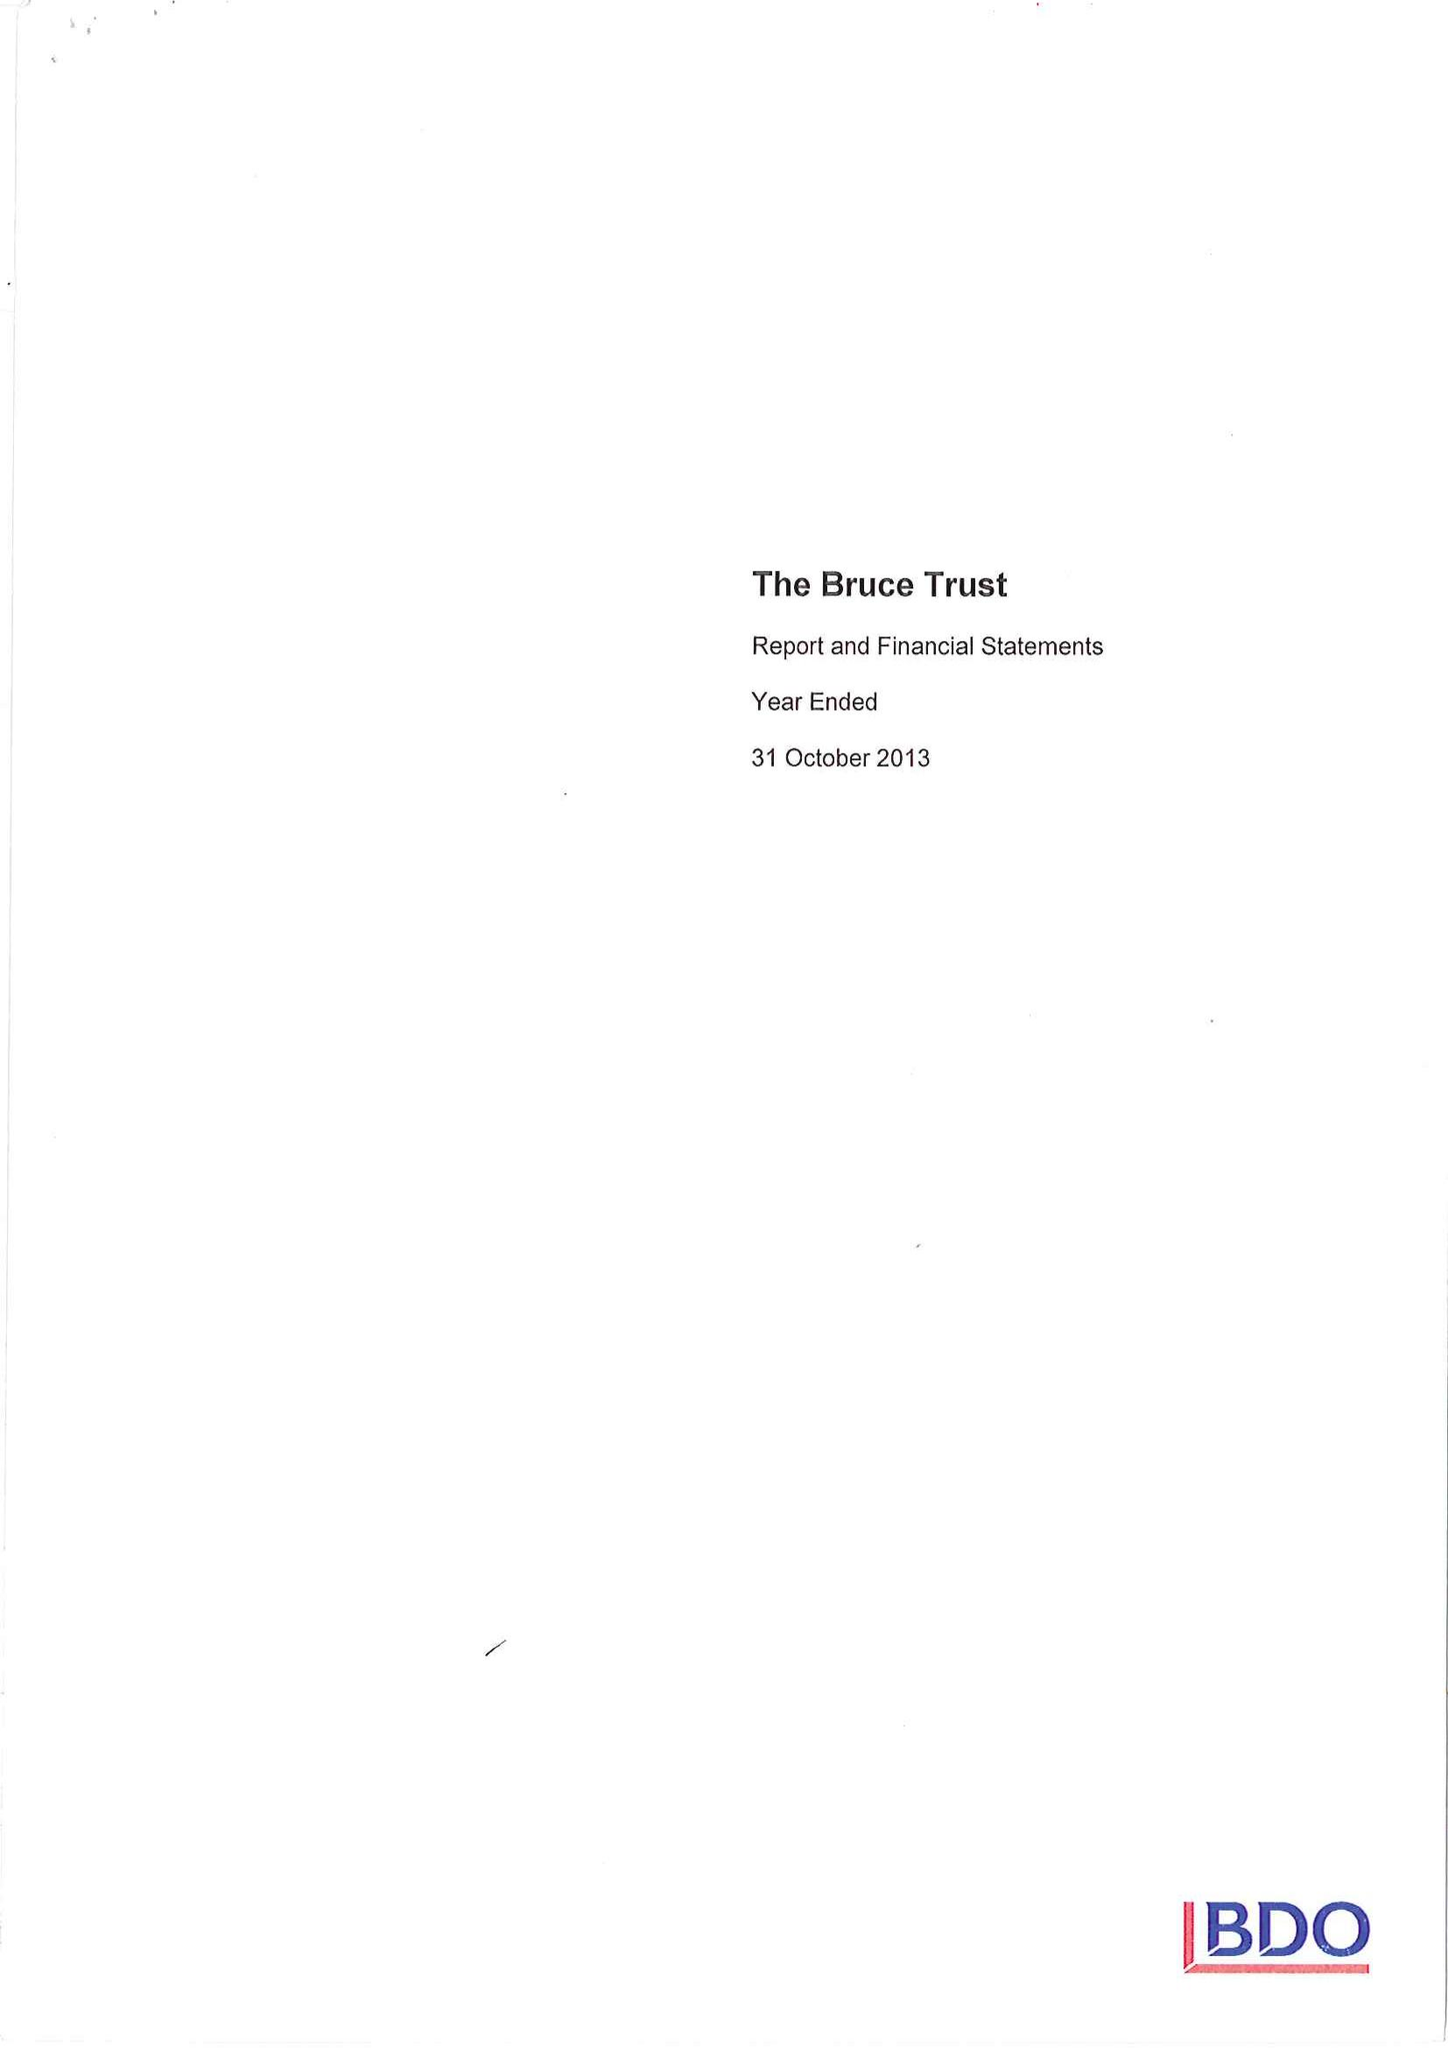What is the value for the income_annually_in_british_pounds?
Answer the question using a single word or phrase. 175027.00 